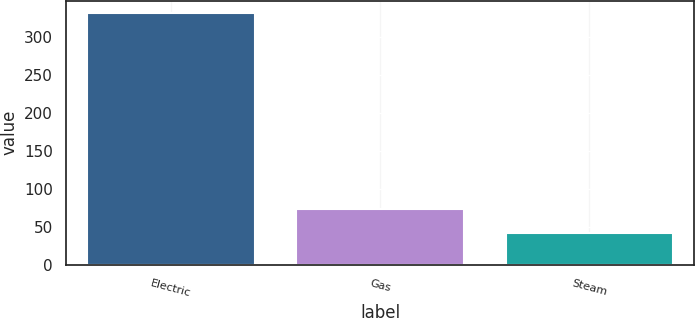Convert chart. <chart><loc_0><loc_0><loc_500><loc_500><bar_chart><fcel>Electric<fcel>Gas<fcel>Steam<nl><fcel>331<fcel>73<fcel>42<nl></chart> 